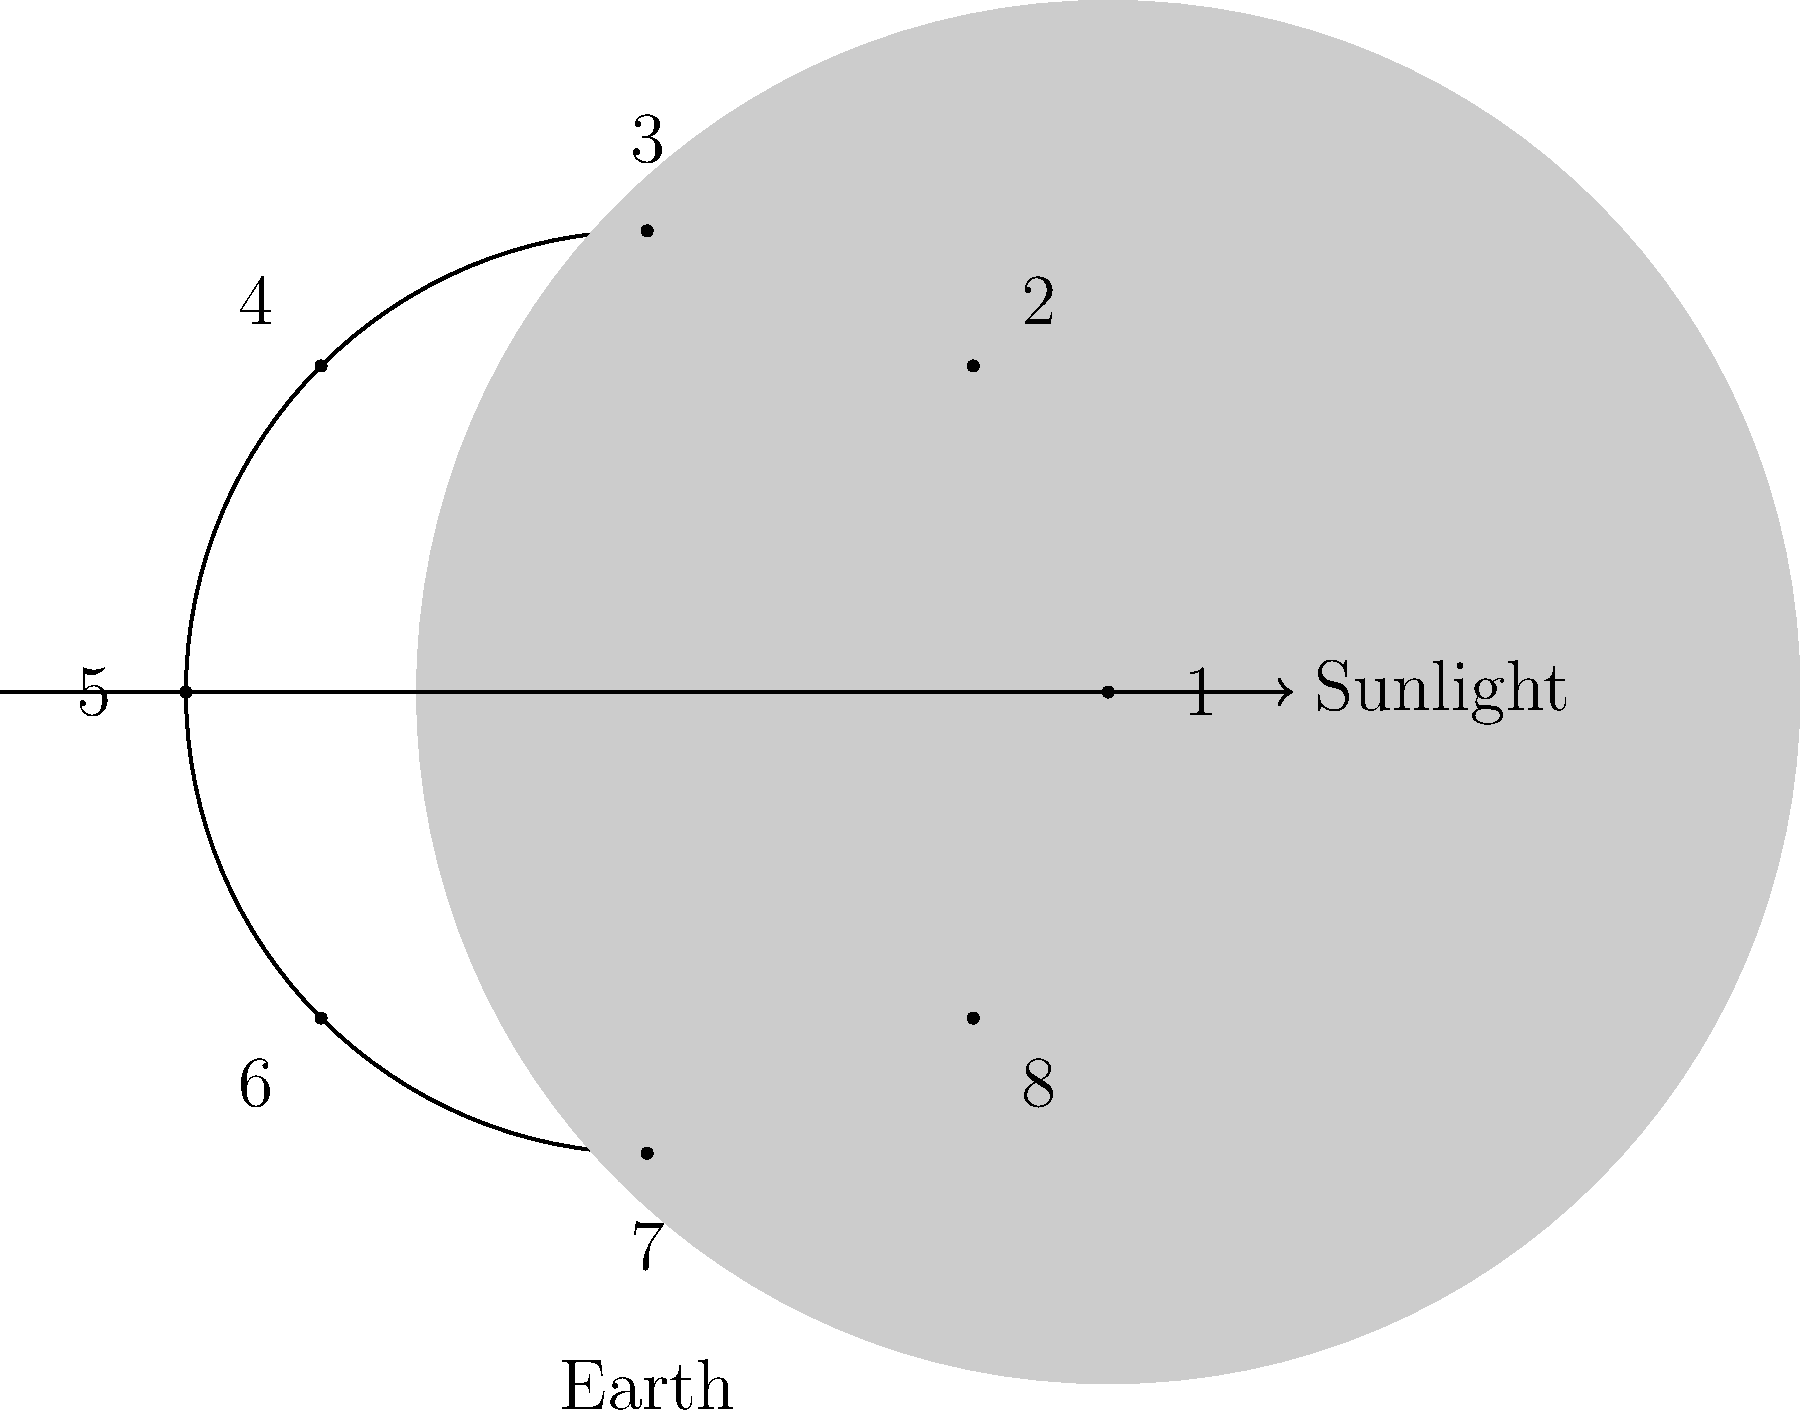As a field nurse accustomed to working night shifts, you're interested in understanding moon phases to plan your schedules better. The diagram shows the phases of the moon during a lunar cycle, numbered 1 to 8. If phase 1 represents the New Moon, which phase number corresponds to the Full Moon, and approximately how many days after the New Moon does it occur? Let's break this down step-by-step:

1. The diagram shows a complete lunar cycle, divided into 8 phases.

2. We know that phase 1 is the New Moon, where the moon is between the Earth and the Sun, and its dark side faces Earth.

3. As we move counter-clockwise in the diagram, we see the illuminated portion of the moon increasing.

4. The Full Moon occurs when the entire face of the moon visible from Earth is illuminated. This happens when the Earth is between the Sun and the Moon.

5. In the diagram, this corresponds to phase 5, directly opposite to phase 1 (New Moon).

6. To calculate the number of days:
   - A complete lunar cycle (from one New Moon to the next) takes approximately 29.5 days.
   - The diagram divides this into 8 phases.
   - So, each phase lasts approximately 29.5 / 8 ≈ 3.7 days.
   - The Full Moon (phase 5) is 4 phases after the New Moon.
   - Therefore, the Full Moon occurs approximately 4 * 3.7 ≈ 14.8 days after the New Moon.

7. Rounding to the nearest whole number, we can say the Full Moon occurs about 15 days after the New Moon.
Answer: Phase 5, approximately 15 days after New Moon 